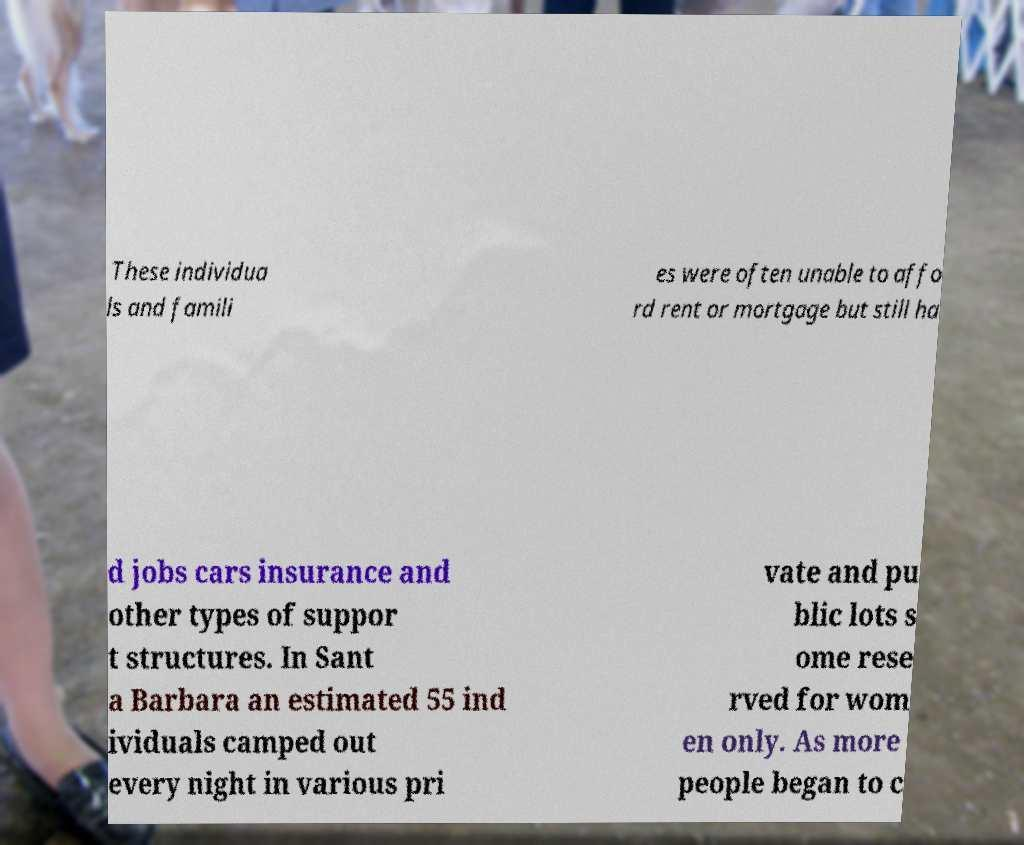Can you accurately transcribe the text from the provided image for me? These individua ls and famili es were often unable to affo rd rent or mortgage but still ha d jobs cars insurance and other types of suppor t structures. In Sant a Barbara an estimated 55 ind ividuals camped out every night in various pri vate and pu blic lots s ome rese rved for wom en only. As more people began to c 